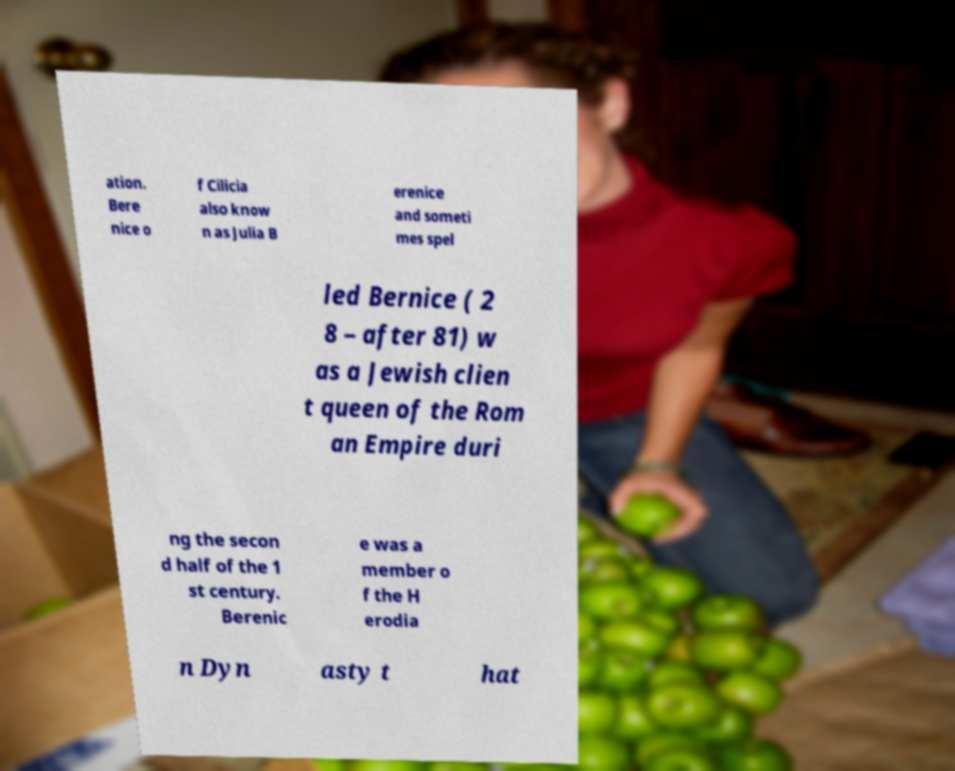Please identify and transcribe the text found in this image. ation. Bere nice o f Cilicia also know n as Julia B erenice and someti mes spel led Bernice ( 2 8 – after 81) w as a Jewish clien t queen of the Rom an Empire duri ng the secon d half of the 1 st century. Berenic e was a member o f the H erodia n Dyn asty t hat 